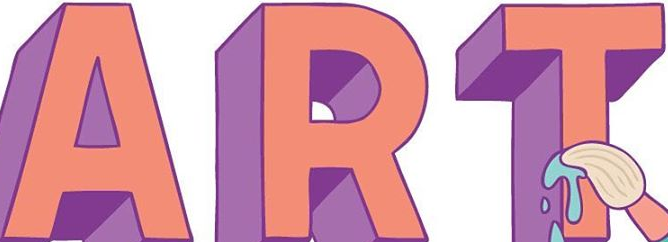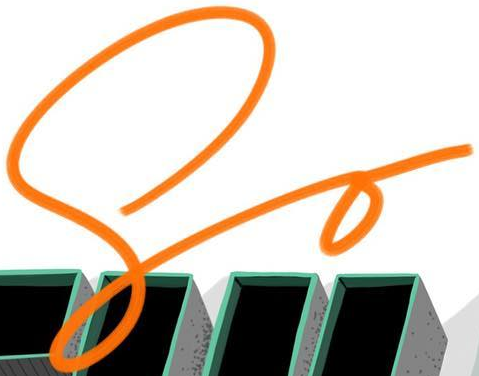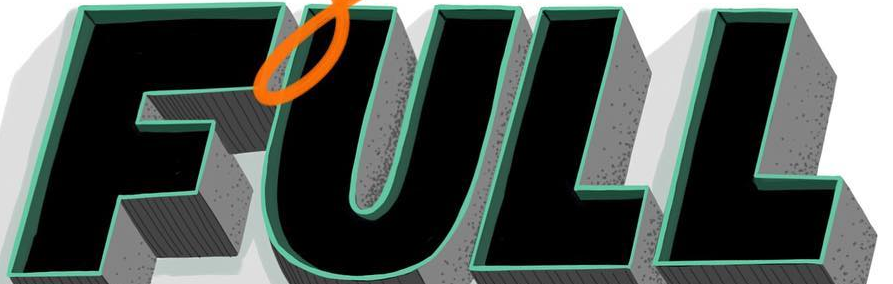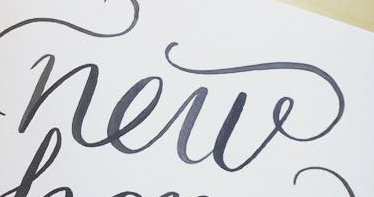What words can you see in these images in sequence, separated by a semicolon? ART; So; FULL; new 